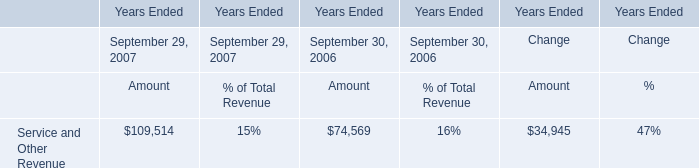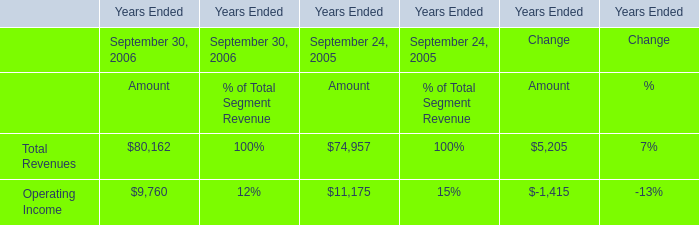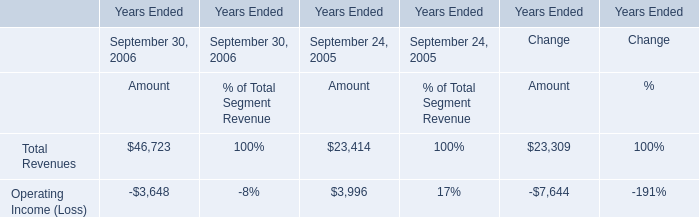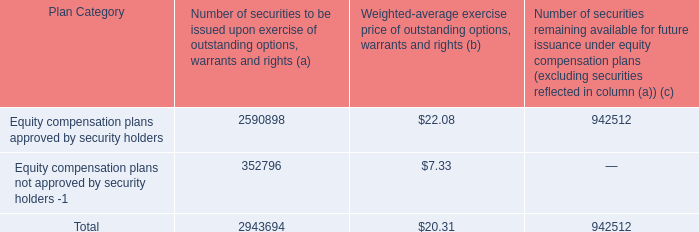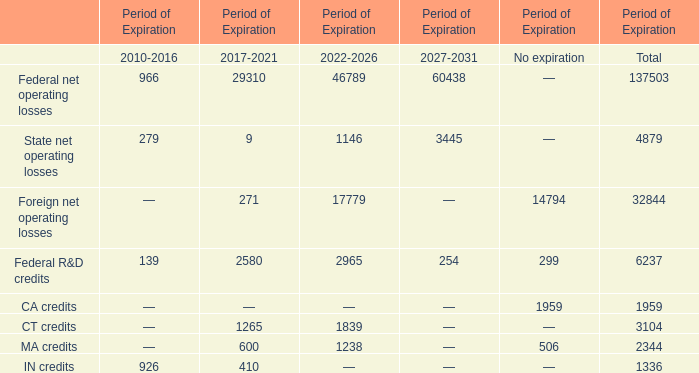What is the average value of Total Revenues for Amount and Service and Other Revenue in 2006 ? 
Computations: ((46723 + 74569) / 2)
Answer: 60646.0. 